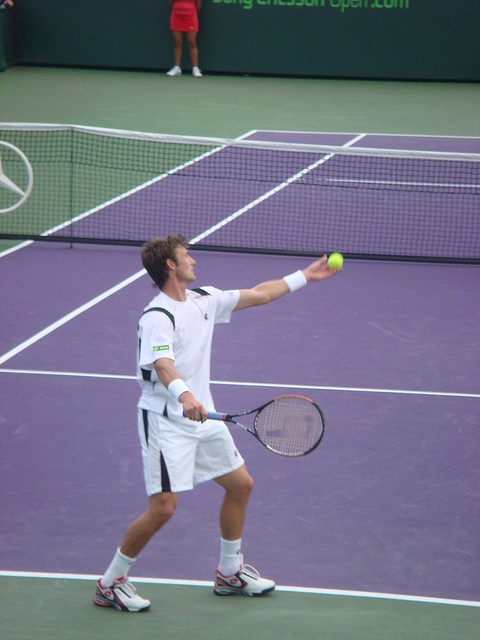Describe the objects in this image and their specific colors. I can see people in black, lavender, darkgray, and gray tones, tennis racket in black and gray tones, people in black, brown, and maroon tones, and sports ball in black, khaki, olive, lightgreen, and gray tones in this image. 